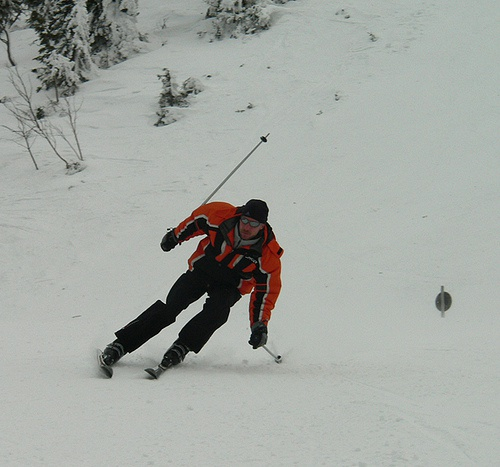Describe the objects in this image and their specific colors. I can see people in black, maroon, darkgray, and gray tones and skis in black, gray, and darkgray tones in this image. 